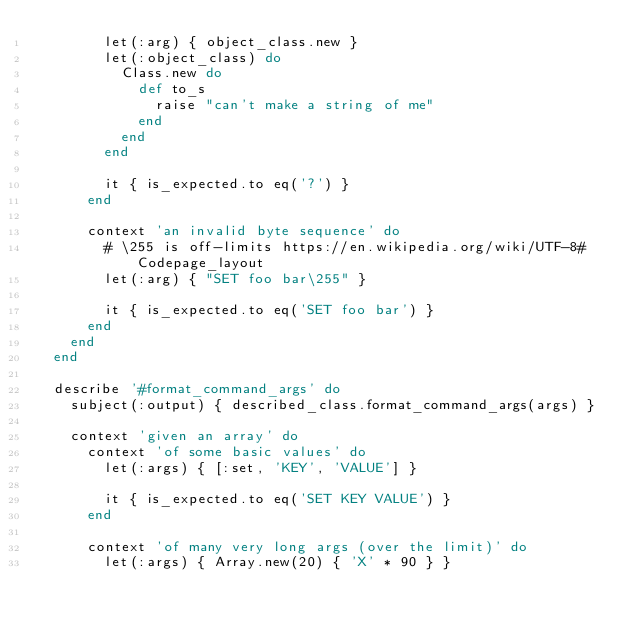<code> <loc_0><loc_0><loc_500><loc_500><_Ruby_>        let(:arg) { object_class.new }
        let(:object_class) do
          Class.new do
            def to_s
              raise "can't make a string of me"
            end
          end
        end

        it { is_expected.to eq('?') }
      end

      context 'an invalid byte sequence' do
        # \255 is off-limits https://en.wikipedia.org/wiki/UTF-8#Codepage_layout
        let(:arg) { "SET foo bar\255" }

        it { is_expected.to eq('SET foo bar') }
      end
    end
  end

  describe '#format_command_args' do
    subject(:output) { described_class.format_command_args(args) }

    context 'given an array' do
      context 'of some basic values' do
        let(:args) { [:set, 'KEY', 'VALUE'] }

        it { is_expected.to eq('SET KEY VALUE') }
      end

      context 'of many very long args (over the limit)' do
        let(:args) { Array.new(20) { 'X' * 90 } }
</code> 